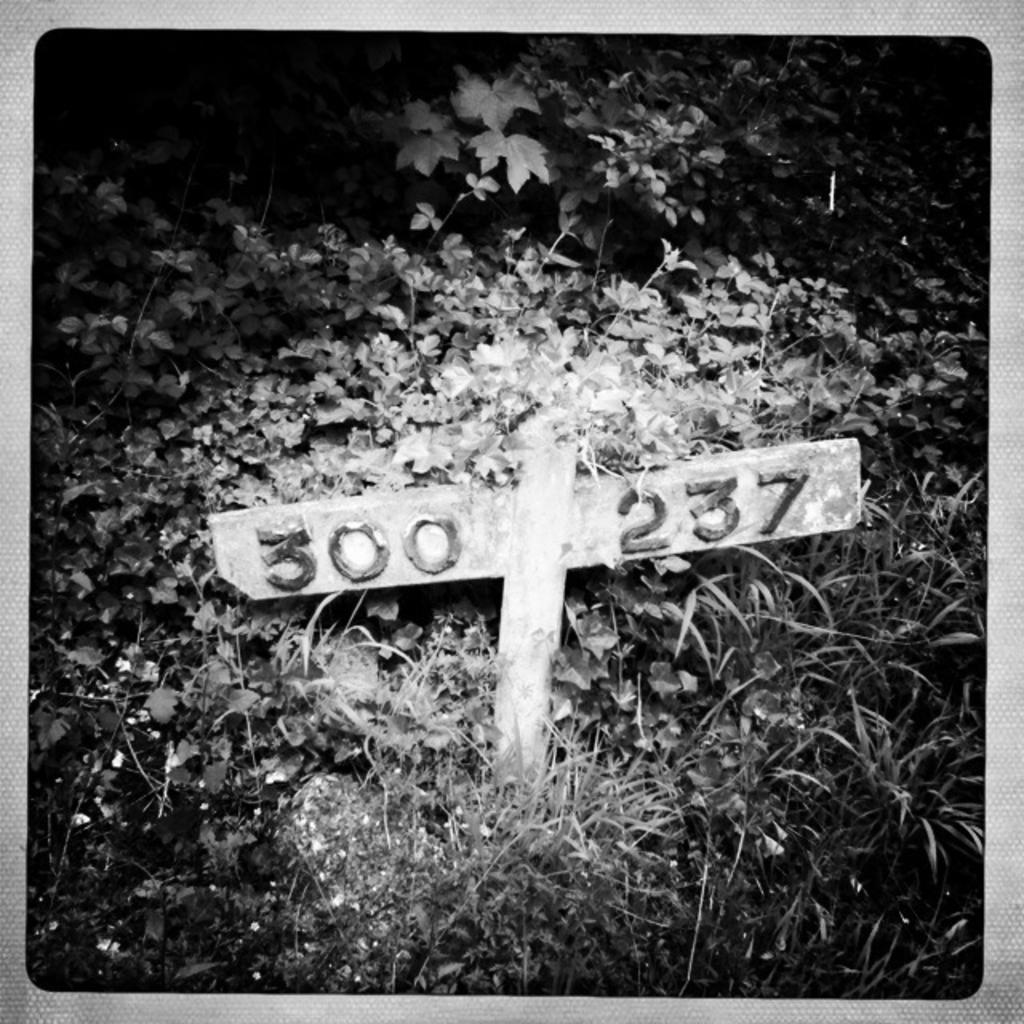<image>
Give a short and clear explanation of the subsequent image. a wooden gross that says 300 and 237 on it 